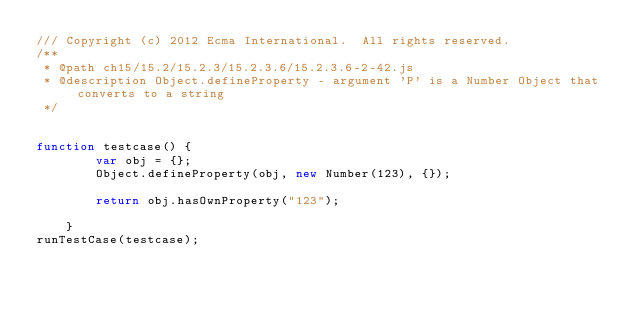Convert code to text. <code><loc_0><loc_0><loc_500><loc_500><_JavaScript_>/// Copyright (c) 2012 Ecma International.  All rights reserved. 
/**
 * @path ch15/15.2/15.2.3/15.2.3.6/15.2.3.6-2-42.js
 * @description Object.defineProperty - argument 'P' is a Number Object that converts to a string
 */


function testcase() {
        var obj = {};
        Object.defineProperty(obj, new Number(123), {});

        return obj.hasOwnProperty("123");

    }
runTestCase(testcase);
</code> 